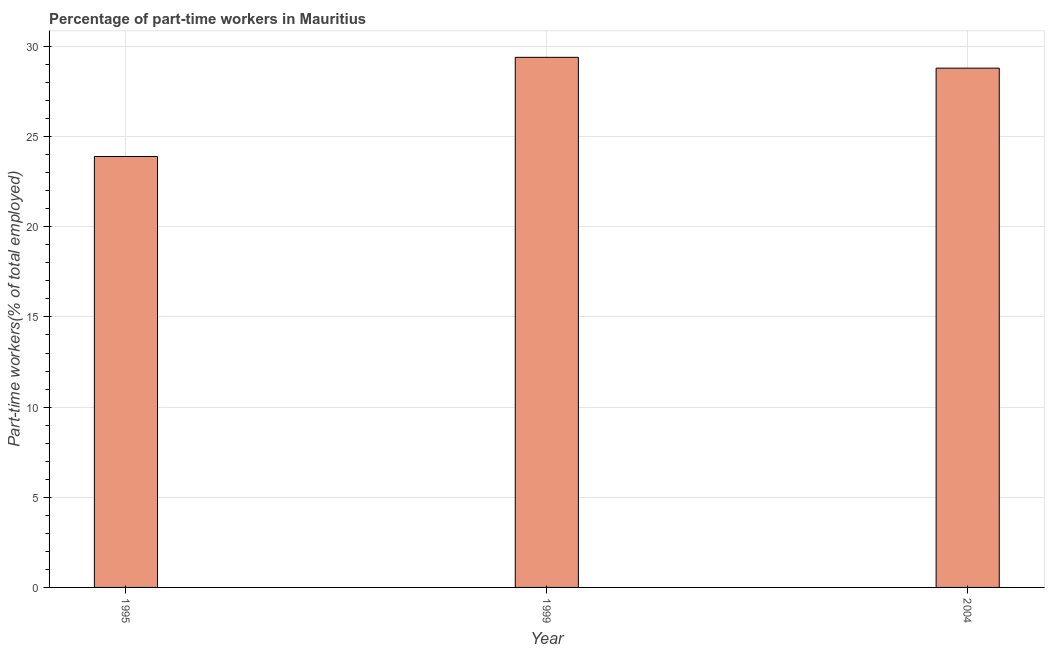Does the graph contain grids?
Your answer should be very brief. Yes. What is the title of the graph?
Offer a terse response. Percentage of part-time workers in Mauritius. What is the label or title of the X-axis?
Give a very brief answer. Year. What is the label or title of the Y-axis?
Provide a short and direct response. Part-time workers(% of total employed). What is the percentage of part-time workers in 1995?
Make the answer very short. 23.9. Across all years, what is the maximum percentage of part-time workers?
Your answer should be very brief. 29.4. Across all years, what is the minimum percentage of part-time workers?
Provide a short and direct response. 23.9. In which year was the percentage of part-time workers minimum?
Provide a succinct answer. 1995. What is the sum of the percentage of part-time workers?
Give a very brief answer. 82.1. What is the average percentage of part-time workers per year?
Keep it short and to the point. 27.37. What is the median percentage of part-time workers?
Provide a short and direct response. 28.8. Do a majority of the years between 1999 and 1995 (inclusive) have percentage of part-time workers greater than 29 %?
Your answer should be compact. No. What is the ratio of the percentage of part-time workers in 1995 to that in 2004?
Offer a very short reply. 0.83. Is the percentage of part-time workers in 1995 less than that in 1999?
Give a very brief answer. Yes. Is the difference between the percentage of part-time workers in 1999 and 2004 greater than the difference between any two years?
Provide a succinct answer. No. Is the sum of the percentage of part-time workers in 1995 and 2004 greater than the maximum percentage of part-time workers across all years?
Your answer should be compact. Yes. In how many years, is the percentage of part-time workers greater than the average percentage of part-time workers taken over all years?
Ensure brevity in your answer.  2. How many bars are there?
Offer a very short reply. 3. How many years are there in the graph?
Provide a succinct answer. 3. What is the Part-time workers(% of total employed) of 1995?
Your answer should be very brief. 23.9. What is the Part-time workers(% of total employed) of 1999?
Ensure brevity in your answer.  29.4. What is the Part-time workers(% of total employed) of 2004?
Your answer should be compact. 28.8. What is the difference between the Part-time workers(% of total employed) in 1995 and 1999?
Make the answer very short. -5.5. What is the difference between the Part-time workers(% of total employed) in 1999 and 2004?
Your response must be concise. 0.6. What is the ratio of the Part-time workers(% of total employed) in 1995 to that in 1999?
Give a very brief answer. 0.81. What is the ratio of the Part-time workers(% of total employed) in 1995 to that in 2004?
Offer a terse response. 0.83. What is the ratio of the Part-time workers(% of total employed) in 1999 to that in 2004?
Ensure brevity in your answer.  1.02. 